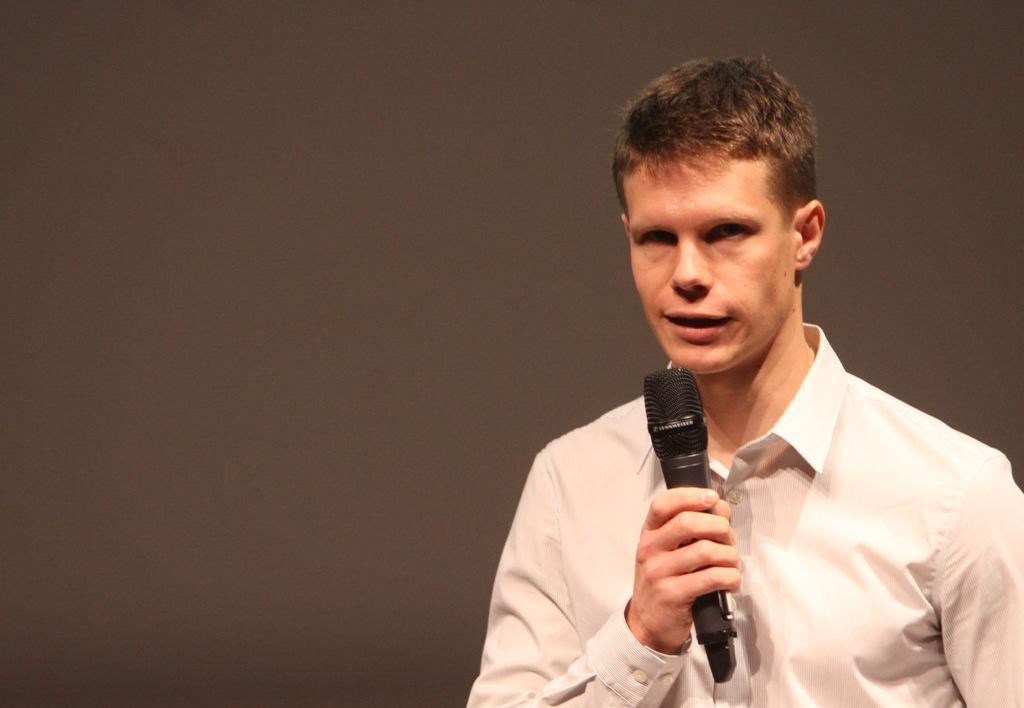What is the main subject of the image? There is a person in the image. What is the person holding in the image? The person is holding a microphone (mike). How many letters are visible on the wax van in the image? There is no wax van present in the image, and therefore no letters can be observed on it. 